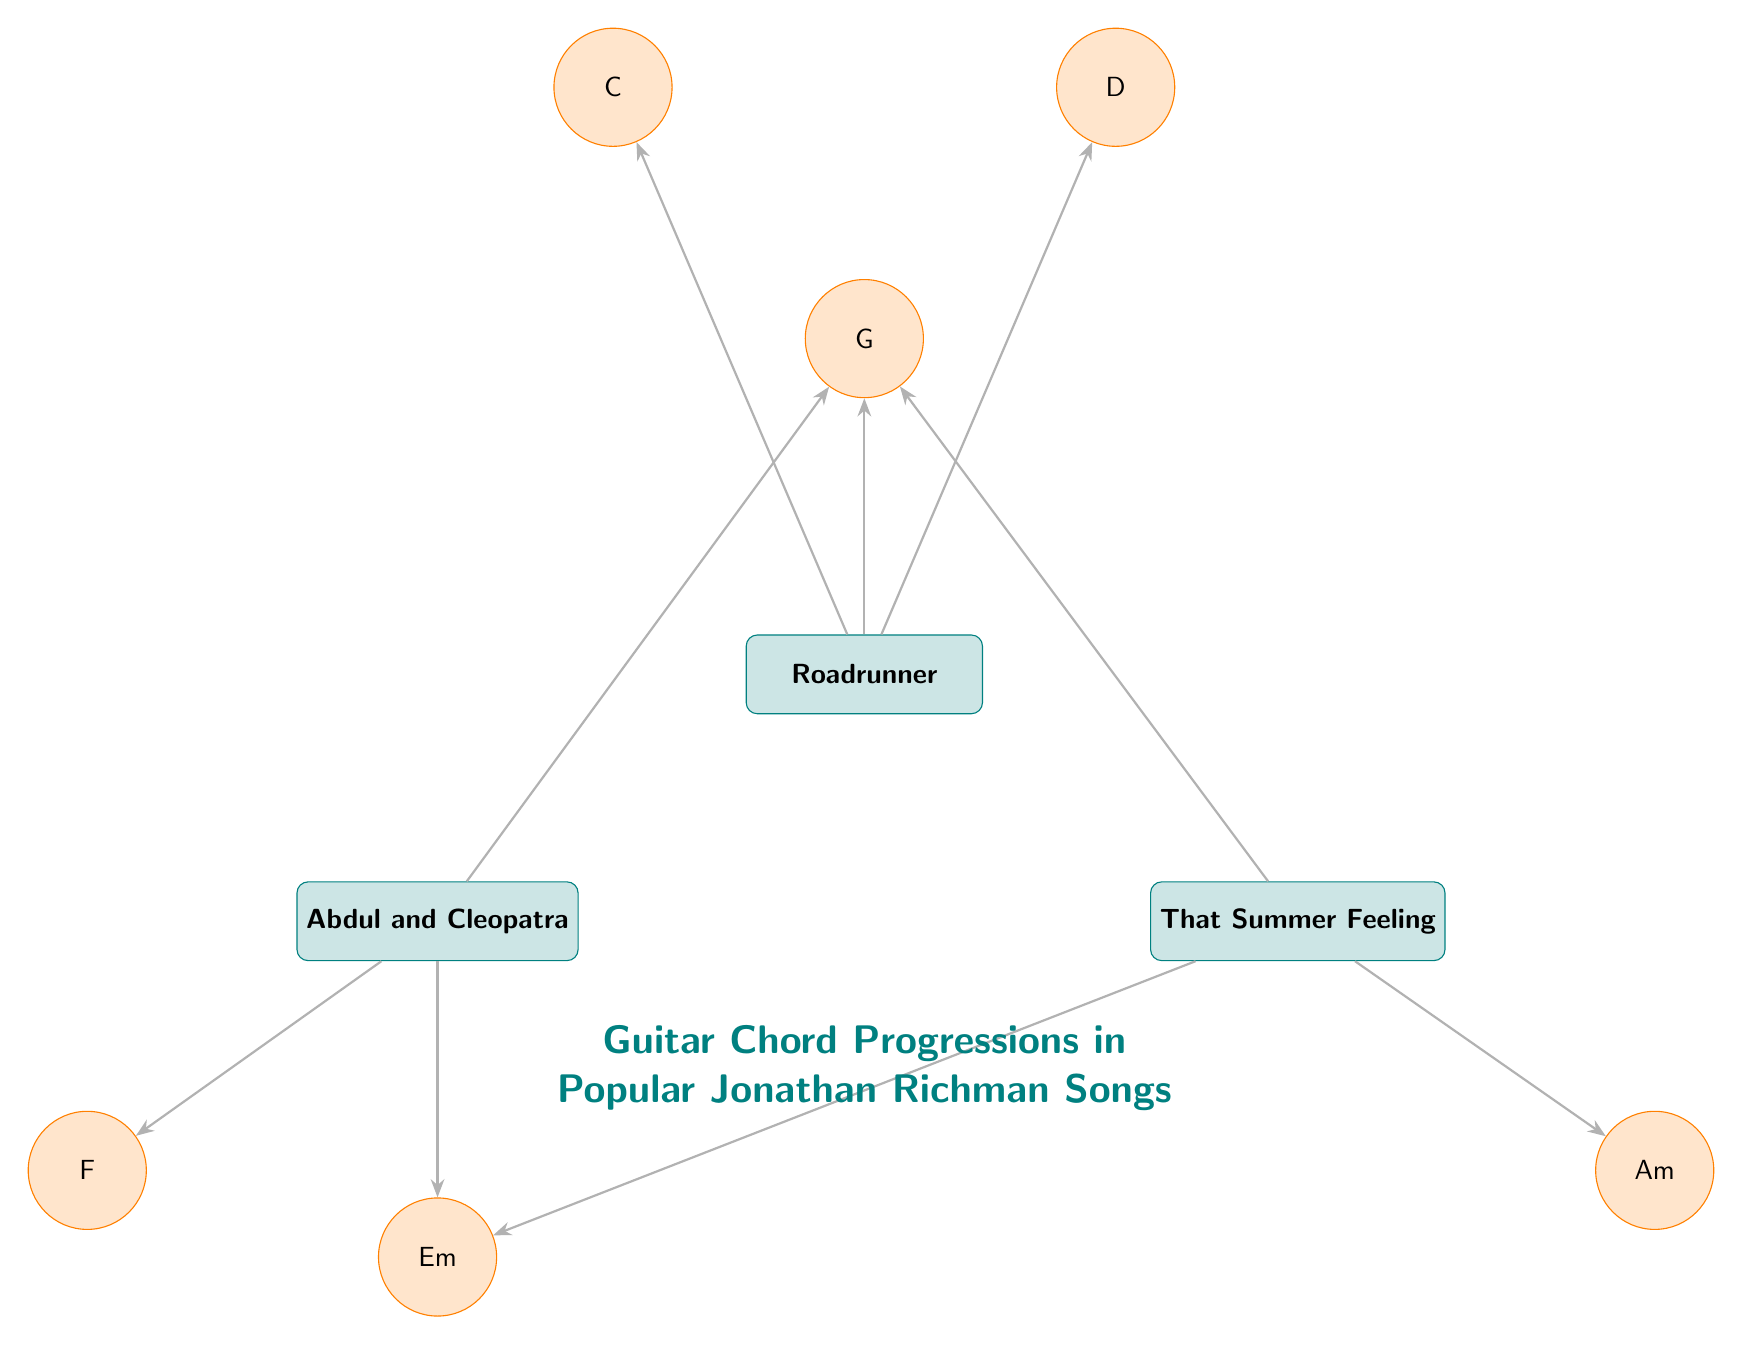What songs use the G chord? By examining the diagram, we can see that both "Roadrunner," "Abdul and Cleopatra," and "That Summer Feeling" are connected to the G chord. Therefore, we identify these songs as using the chord G.
Answer: Roadrunner, Abdul and Cleopatra, That Summer Feeling How many different chords are represented in the diagram? The diagram shows the chords G, C, D, F, Em, and Am, which are a total of 6 unique chords. Thus, we count each chord in the diagram to arrive at this number.
Answer: 6 Which song uses the Am chord? Looking at the diagram, it is clear that the only song that connects to the Am chord is "That Summer Feeling." We can directly trace the edge from "That Summer Feeling" to the Am chord.
Answer: That Summer Feeling What are the connections for "Abdul and Cleopatra"? The diagram indicates that "Abdul and Cleopatra" connects to three chords: G, F, and Em. We trace the edges from this song node to each of the chord nodes to identify all connections.
Answer: G, F, Em Which chord is used in both "Roadrunner" and "That Summer Feeling"? Both "Roadrunner" and "That Summer Feeling" share a connection to the G chord. By checking the connections for each song, we confirm that G is the common chord they use.
Answer: G How many songs are represented in the diagram? The diagram contains three song nodes: "Roadrunner," "Abdul and Cleopatra," and "That Summer Feeling." Thus, by simply counting each song node in the diagram, we find the total number.
Answer: 3 What is the relationship between "That Summer Feeling" and the Em chord? The diagram shows a direct edge connecting "That Summer Feeling" to the Em chord, indicating that this song uses the Em chord. Therefore, we recognize this relationship as a use of the Em chord by the song.
Answer: Uses Em 